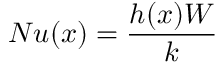<formula> <loc_0><loc_0><loc_500><loc_500>N u ( x ) = \frac { h ( x ) W } { k }</formula> 